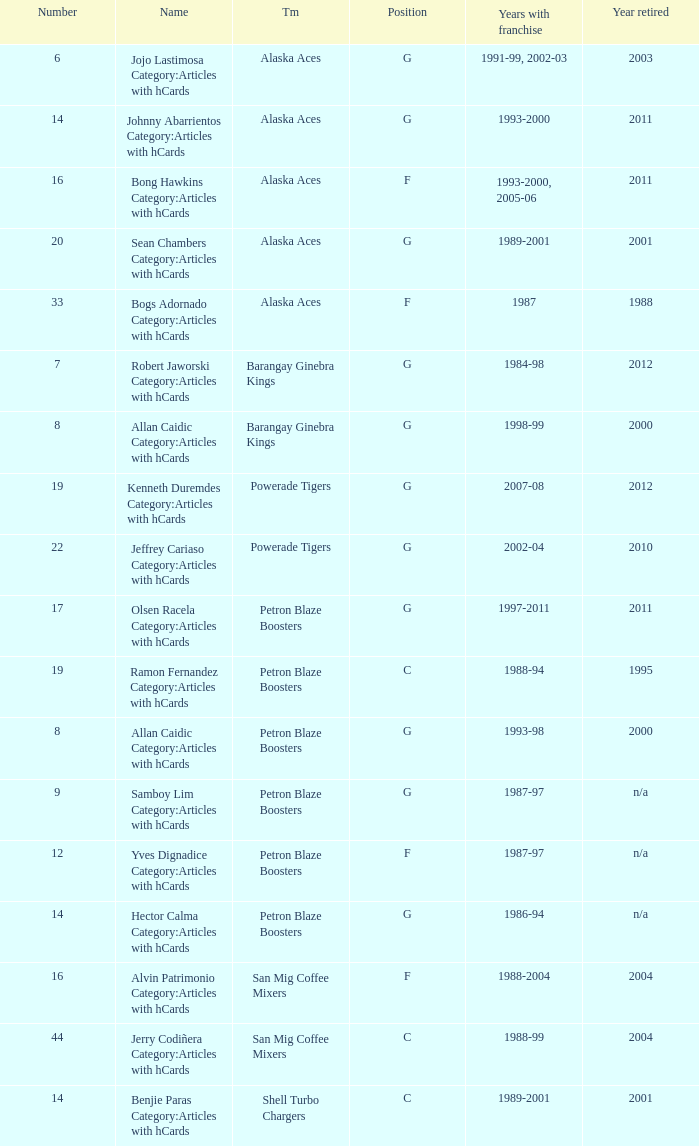Which team is number 14 and had a franchise in 1993-2000? Alaska Aces. 